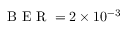Convert formula to latex. <formula><loc_0><loc_0><loc_500><loc_500>B E R = 2 \times 1 0 ^ { - 3 }</formula> 